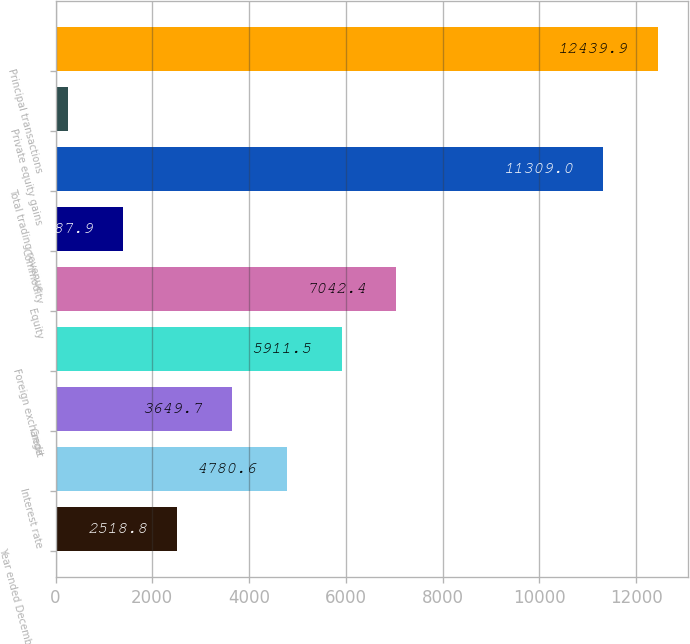Convert chart to OTSL. <chart><loc_0><loc_0><loc_500><loc_500><bar_chart><fcel>Year ended December 31 (in<fcel>Interest rate<fcel>Credit<fcel>Foreign exchange<fcel>Equity<fcel>Commodity<fcel>Total trading revenue<fcel>Private equity gains<fcel>Principal transactions<nl><fcel>2518.8<fcel>4780.6<fcel>3649.7<fcel>5911.5<fcel>7042.4<fcel>1387.9<fcel>11309<fcel>257<fcel>12439.9<nl></chart> 